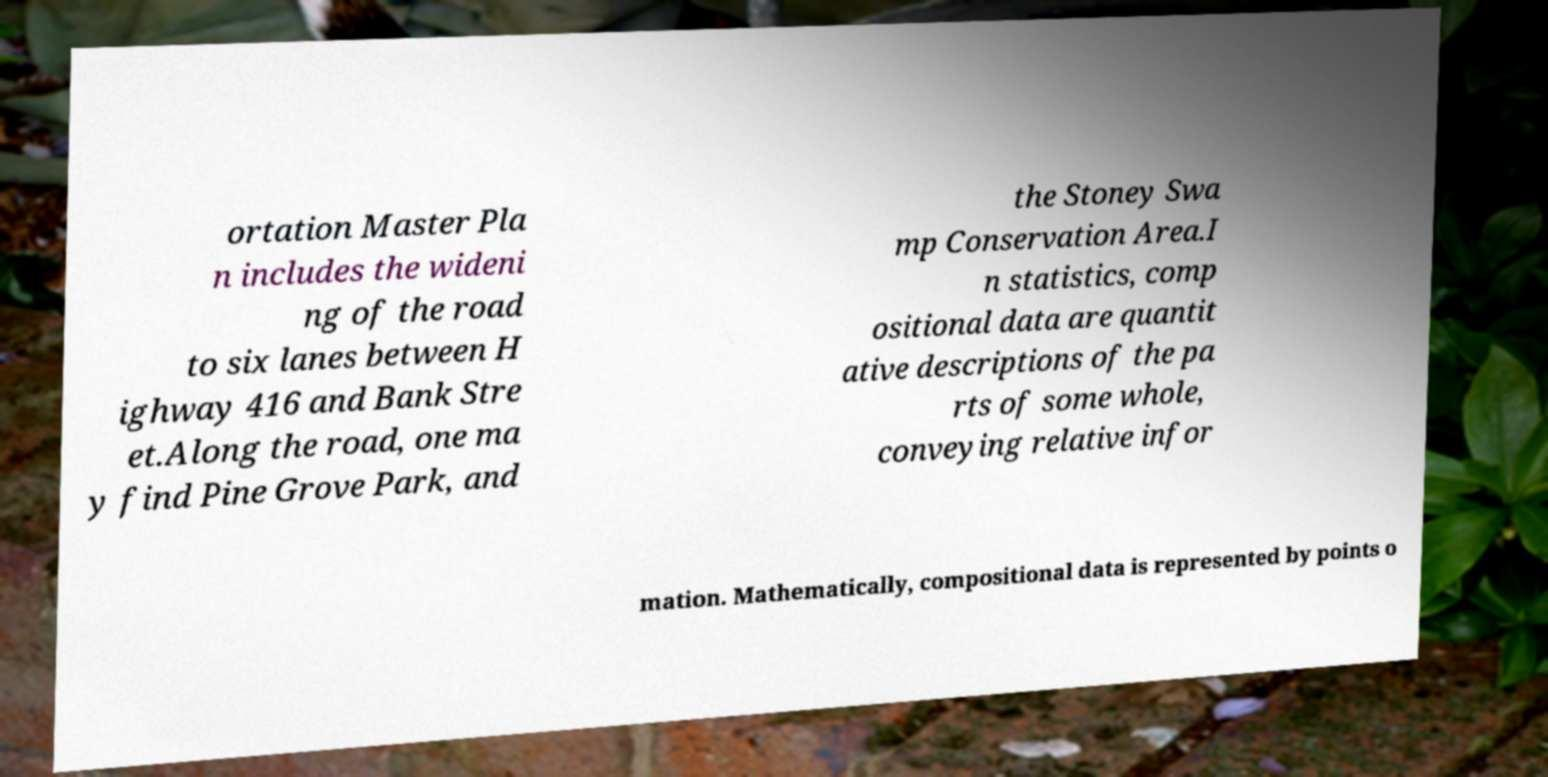For documentation purposes, I need the text within this image transcribed. Could you provide that? ortation Master Pla n includes the wideni ng of the road to six lanes between H ighway 416 and Bank Stre et.Along the road, one ma y find Pine Grove Park, and the Stoney Swa mp Conservation Area.I n statistics, comp ositional data are quantit ative descriptions of the pa rts of some whole, conveying relative infor mation. Mathematically, compositional data is represented by points o 